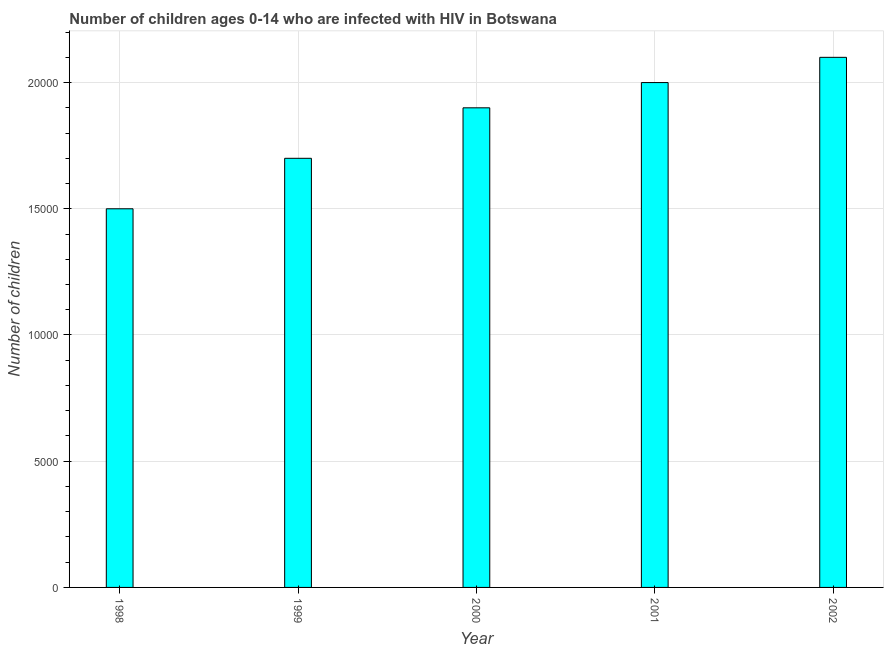What is the title of the graph?
Keep it short and to the point. Number of children ages 0-14 who are infected with HIV in Botswana. What is the label or title of the X-axis?
Provide a succinct answer. Year. What is the label or title of the Y-axis?
Ensure brevity in your answer.  Number of children. What is the number of children living with hiv in 1999?
Provide a succinct answer. 1.70e+04. Across all years, what is the maximum number of children living with hiv?
Provide a succinct answer. 2.10e+04. Across all years, what is the minimum number of children living with hiv?
Provide a succinct answer. 1.50e+04. In which year was the number of children living with hiv maximum?
Provide a succinct answer. 2002. What is the sum of the number of children living with hiv?
Your answer should be compact. 9.20e+04. What is the difference between the number of children living with hiv in 2000 and 2001?
Your answer should be compact. -1000. What is the average number of children living with hiv per year?
Offer a very short reply. 1.84e+04. What is the median number of children living with hiv?
Keep it short and to the point. 1.90e+04. In how many years, is the number of children living with hiv greater than 21000 ?
Provide a short and direct response. 0. What is the ratio of the number of children living with hiv in 1999 to that in 2001?
Provide a short and direct response. 0.85. Is the number of children living with hiv in 1998 less than that in 1999?
Make the answer very short. Yes. Is the sum of the number of children living with hiv in 1998 and 2000 greater than the maximum number of children living with hiv across all years?
Offer a terse response. Yes. What is the difference between the highest and the lowest number of children living with hiv?
Your answer should be compact. 6000. How many bars are there?
Your response must be concise. 5. Are all the bars in the graph horizontal?
Offer a very short reply. No. Are the values on the major ticks of Y-axis written in scientific E-notation?
Make the answer very short. No. What is the Number of children in 1998?
Offer a very short reply. 1.50e+04. What is the Number of children of 1999?
Your answer should be very brief. 1.70e+04. What is the Number of children of 2000?
Your answer should be very brief. 1.90e+04. What is the Number of children in 2002?
Give a very brief answer. 2.10e+04. What is the difference between the Number of children in 1998 and 1999?
Your answer should be very brief. -2000. What is the difference between the Number of children in 1998 and 2000?
Give a very brief answer. -4000. What is the difference between the Number of children in 1998 and 2001?
Your answer should be very brief. -5000. What is the difference between the Number of children in 1998 and 2002?
Your response must be concise. -6000. What is the difference between the Number of children in 1999 and 2000?
Keep it short and to the point. -2000. What is the difference between the Number of children in 1999 and 2001?
Your answer should be compact. -3000. What is the difference between the Number of children in 1999 and 2002?
Make the answer very short. -4000. What is the difference between the Number of children in 2000 and 2001?
Make the answer very short. -1000. What is the difference between the Number of children in 2000 and 2002?
Give a very brief answer. -2000. What is the difference between the Number of children in 2001 and 2002?
Make the answer very short. -1000. What is the ratio of the Number of children in 1998 to that in 1999?
Offer a very short reply. 0.88. What is the ratio of the Number of children in 1998 to that in 2000?
Your answer should be very brief. 0.79. What is the ratio of the Number of children in 1998 to that in 2001?
Ensure brevity in your answer.  0.75. What is the ratio of the Number of children in 1998 to that in 2002?
Give a very brief answer. 0.71. What is the ratio of the Number of children in 1999 to that in 2000?
Ensure brevity in your answer.  0.9. What is the ratio of the Number of children in 1999 to that in 2001?
Give a very brief answer. 0.85. What is the ratio of the Number of children in 1999 to that in 2002?
Give a very brief answer. 0.81. What is the ratio of the Number of children in 2000 to that in 2001?
Your answer should be very brief. 0.95. What is the ratio of the Number of children in 2000 to that in 2002?
Ensure brevity in your answer.  0.91. 